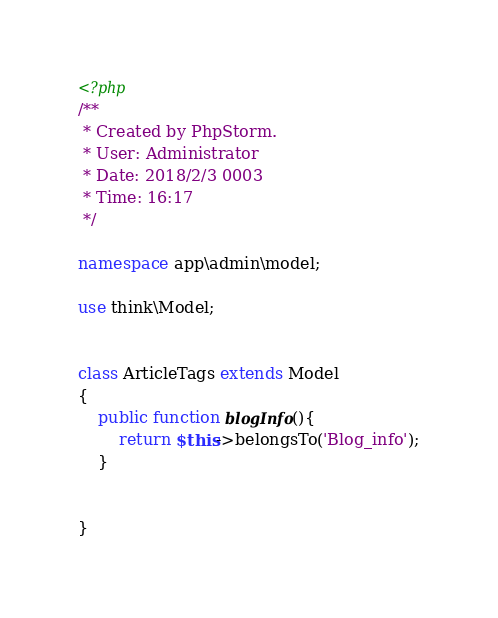<code> <loc_0><loc_0><loc_500><loc_500><_PHP_><?php
/**
 * Created by PhpStorm.
 * User: Administrator
 * Date: 2018/2/3 0003
 * Time: 16:17
 */

namespace app\admin\model;

use think\Model;


class ArticleTags extends Model
{
    public function blogInfo(){
        return $this->belongsTo('Blog_info');
    }


}</code> 